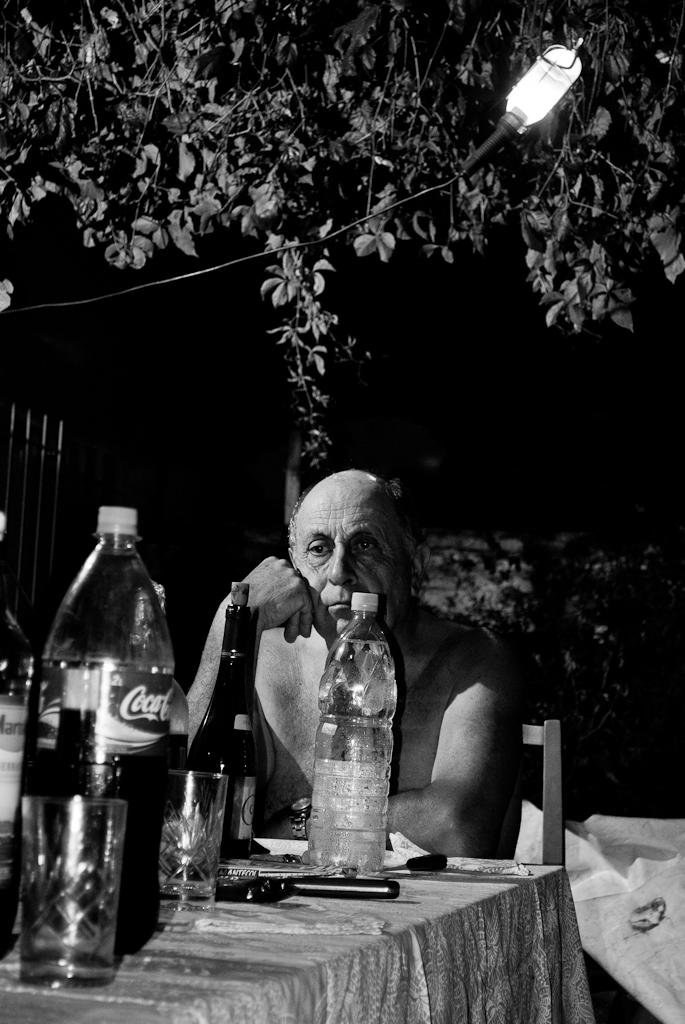<image>
Provide a brief description of the given image. A depressed looking man sits at a table with different beverages including Coca Cola. 